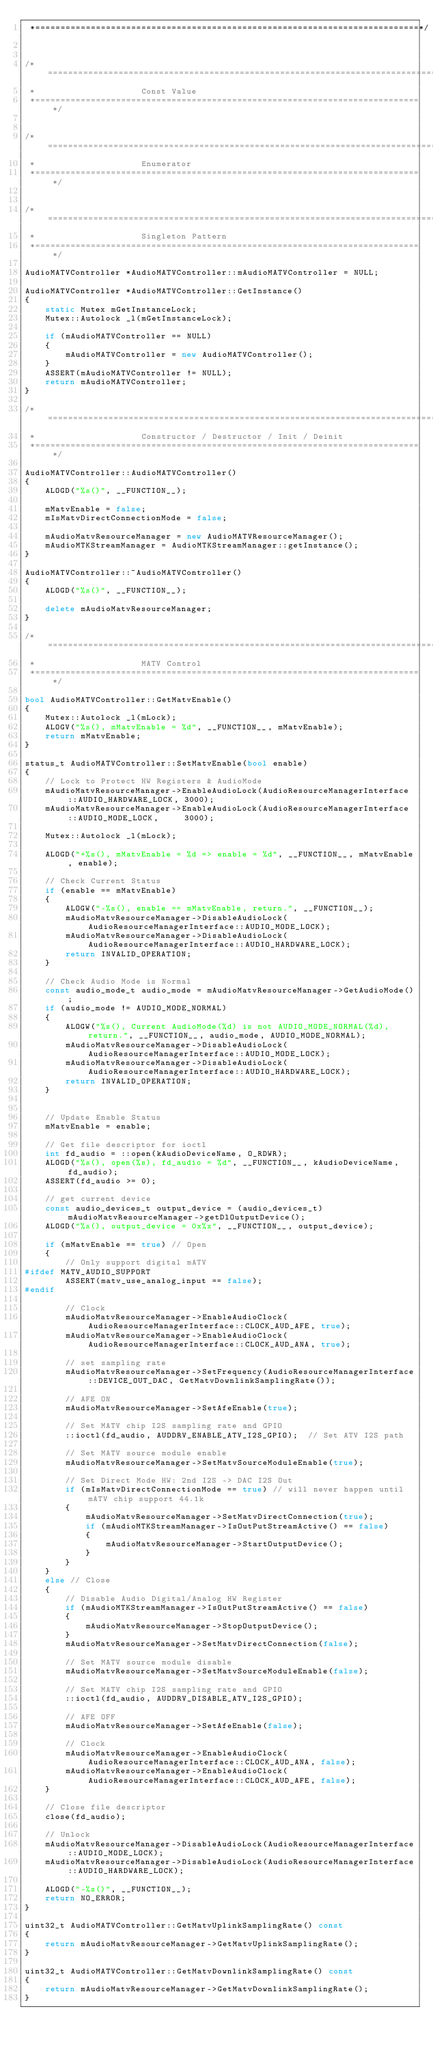Convert code to text. <code><loc_0><loc_0><loc_500><loc_500><_C++_> *============================================================================*/


/*==============================================================================
 *                     Const Value
 *============================================================================*/


/*==============================================================================
 *                     Enumerator
 *============================================================================*/


/*==============================================================================
 *                     Singleton Pattern
 *============================================================================*/

AudioMATVController *AudioMATVController::mAudioMATVController = NULL;

AudioMATVController *AudioMATVController::GetInstance()
{
    static Mutex mGetInstanceLock;
    Mutex::Autolock _l(mGetInstanceLock);

    if (mAudioMATVController == NULL)
    {
        mAudioMATVController = new AudioMATVController();
    }
    ASSERT(mAudioMATVController != NULL);
    return mAudioMATVController;
}

/*==============================================================================
 *                     Constructor / Destructor / Init / Deinit
 *============================================================================*/

AudioMATVController::AudioMATVController()
{
    ALOGD("%s()", __FUNCTION__);

    mMatvEnable = false;
    mIsMatvDirectConnectionMode = false;

    mAudioMatvResourceManager = new AudioMATVResourceManager();
    mAudioMTKStreamManager = AudioMTKStreamManager::getInstance();
}

AudioMATVController::~AudioMATVController()
{
    ALOGD("%s()", __FUNCTION__);

    delete mAudioMatvResourceManager;
}

/*==============================================================================
 *                     MATV Control
 *============================================================================*/

bool AudioMATVController::GetMatvEnable()
{
    Mutex::Autolock _l(mLock);
    ALOGV("%s(), mMatvEnable = %d", __FUNCTION__, mMatvEnable);
    return mMatvEnable;
}

status_t AudioMATVController::SetMatvEnable(bool enable)
{
    // Lock to Protect HW Registers & AudioMode
    mAudioMatvResourceManager->EnableAudioLock(AudioResourceManagerInterface::AUDIO_HARDWARE_LOCK, 3000);
    mAudioMatvResourceManager->EnableAudioLock(AudioResourceManagerInterface::AUDIO_MODE_LOCK,     3000);

    Mutex::Autolock _l(mLock);

    ALOGD("+%s(), mMatvEnable = %d => enable = %d", __FUNCTION__, mMatvEnable, enable);

    // Check Current Status
    if (enable == mMatvEnable)
    {
        ALOGW("-%s(), enable == mMatvEnable, return.", __FUNCTION__);
        mAudioMatvResourceManager->DisableAudioLock(AudioResourceManagerInterface::AUDIO_MODE_LOCK);
        mAudioMatvResourceManager->DisableAudioLock(AudioResourceManagerInterface::AUDIO_HARDWARE_LOCK);
        return INVALID_OPERATION;
    }

    // Check Audio Mode is Normal
    const audio_mode_t audio_mode = mAudioMatvResourceManager->GetAudioMode();
    if (audio_mode != AUDIO_MODE_NORMAL)
    {
        ALOGW("%s(), Current AudioMode(%d) is not AUDIO_MODE_NORMAL(%d), return.", __FUNCTION__, audio_mode, AUDIO_MODE_NORMAL);
        mAudioMatvResourceManager->DisableAudioLock(AudioResourceManagerInterface::AUDIO_MODE_LOCK);
        mAudioMatvResourceManager->DisableAudioLock(AudioResourceManagerInterface::AUDIO_HARDWARE_LOCK);
        return INVALID_OPERATION;
    }


    // Update Enable Status
    mMatvEnable = enable;

    // Get file descriptor for ioctl
    int fd_audio = ::open(kAudioDeviceName, O_RDWR);
    ALOGD("%s(), open(%s), fd_audio = %d", __FUNCTION__, kAudioDeviceName, fd_audio);
    ASSERT(fd_audio >= 0);

    // get current device
    const audio_devices_t output_device = (audio_devices_t)mAudioMatvResourceManager->getDlOutputDevice();
    ALOGD("%s(), output_device = 0x%x", __FUNCTION__, output_device);

    if (mMatvEnable == true) // Open
    {
        // Only support digital mATV
#ifdef MATV_AUDIO_SUPPORT
        ASSERT(matv_use_analog_input == false);
#endif

        // Clock
        mAudioMatvResourceManager->EnableAudioClock(AudioResourceManagerInterface::CLOCK_AUD_AFE, true);
        mAudioMatvResourceManager->EnableAudioClock(AudioResourceManagerInterface::CLOCK_AUD_ANA, true);

        // set sampling rate
        mAudioMatvResourceManager->SetFrequency(AudioResourceManagerInterface::DEVICE_OUT_DAC, GetMatvDownlinkSamplingRate());

        // AFE ON
        mAudioMatvResourceManager->SetAfeEnable(true);

        // Set MATV chip I2S sampling rate and GPIO
        ::ioctl(fd_audio, AUDDRV_ENABLE_ATV_I2S_GPIO);  // Set ATV I2S path

        // Set MATV source module enable
        mAudioMatvResourceManager->SetMatvSourceModuleEnable(true);

        // Set Direct Mode HW: 2nd I2S -> DAC I2S Out
        if (mIsMatvDirectConnectionMode == true) // will never happen until mATV chip support 44.1k
        {
            mAudioMatvResourceManager->SetMatvDirectConnection(true);
            if (mAudioMTKStreamManager->IsOutPutStreamActive() == false)
            {
                mAudioMatvResourceManager->StartOutputDevice();
            }
        }
    }
    else // Close
    {
        // Disable Audio Digital/Analog HW Register
        if (mAudioMTKStreamManager->IsOutPutStreamActive() == false)
        {
            mAudioMatvResourceManager->StopOutputDevice();
        }
        mAudioMatvResourceManager->SetMatvDirectConnection(false);

        // Set MATV source module disable
        mAudioMatvResourceManager->SetMatvSourceModuleEnable(false);

        // Set MATV chip I2S sampling rate and GPIO
        ::ioctl(fd_audio, AUDDRV_DISABLE_ATV_I2S_GPIO);

        // AFE OFF
        mAudioMatvResourceManager->SetAfeEnable(false);

        // Clock
        mAudioMatvResourceManager->EnableAudioClock(AudioResourceManagerInterface::CLOCK_AUD_ANA, false);
        mAudioMatvResourceManager->EnableAudioClock(AudioResourceManagerInterface::CLOCK_AUD_AFE, false);
    }

    // Close file descriptor
    close(fd_audio);

    // Unlock
    mAudioMatvResourceManager->DisableAudioLock(AudioResourceManagerInterface::AUDIO_MODE_LOCK);
    mAudioMatvResourceManager->DisableAudioLock(AudioResourceManagerInterface::AUDIO_HARDWARE_LOCK);

    ALOGD("-%s()", __FUNCTION__);
    return NO_ERROR;
}

uint32_t AudioMATVController::GetMatvUplinkSamplingRate() const
{
    return mAudioMatvResourceManager->GetMatvUplinkSamplingRate();
}

uint32_t AudioMATVController::GetMatvDownlinkSamplingRate() const
{
    return mAudioMatvResourceManager->GetMatvDownlinkSamplingRate();
}
</code> 